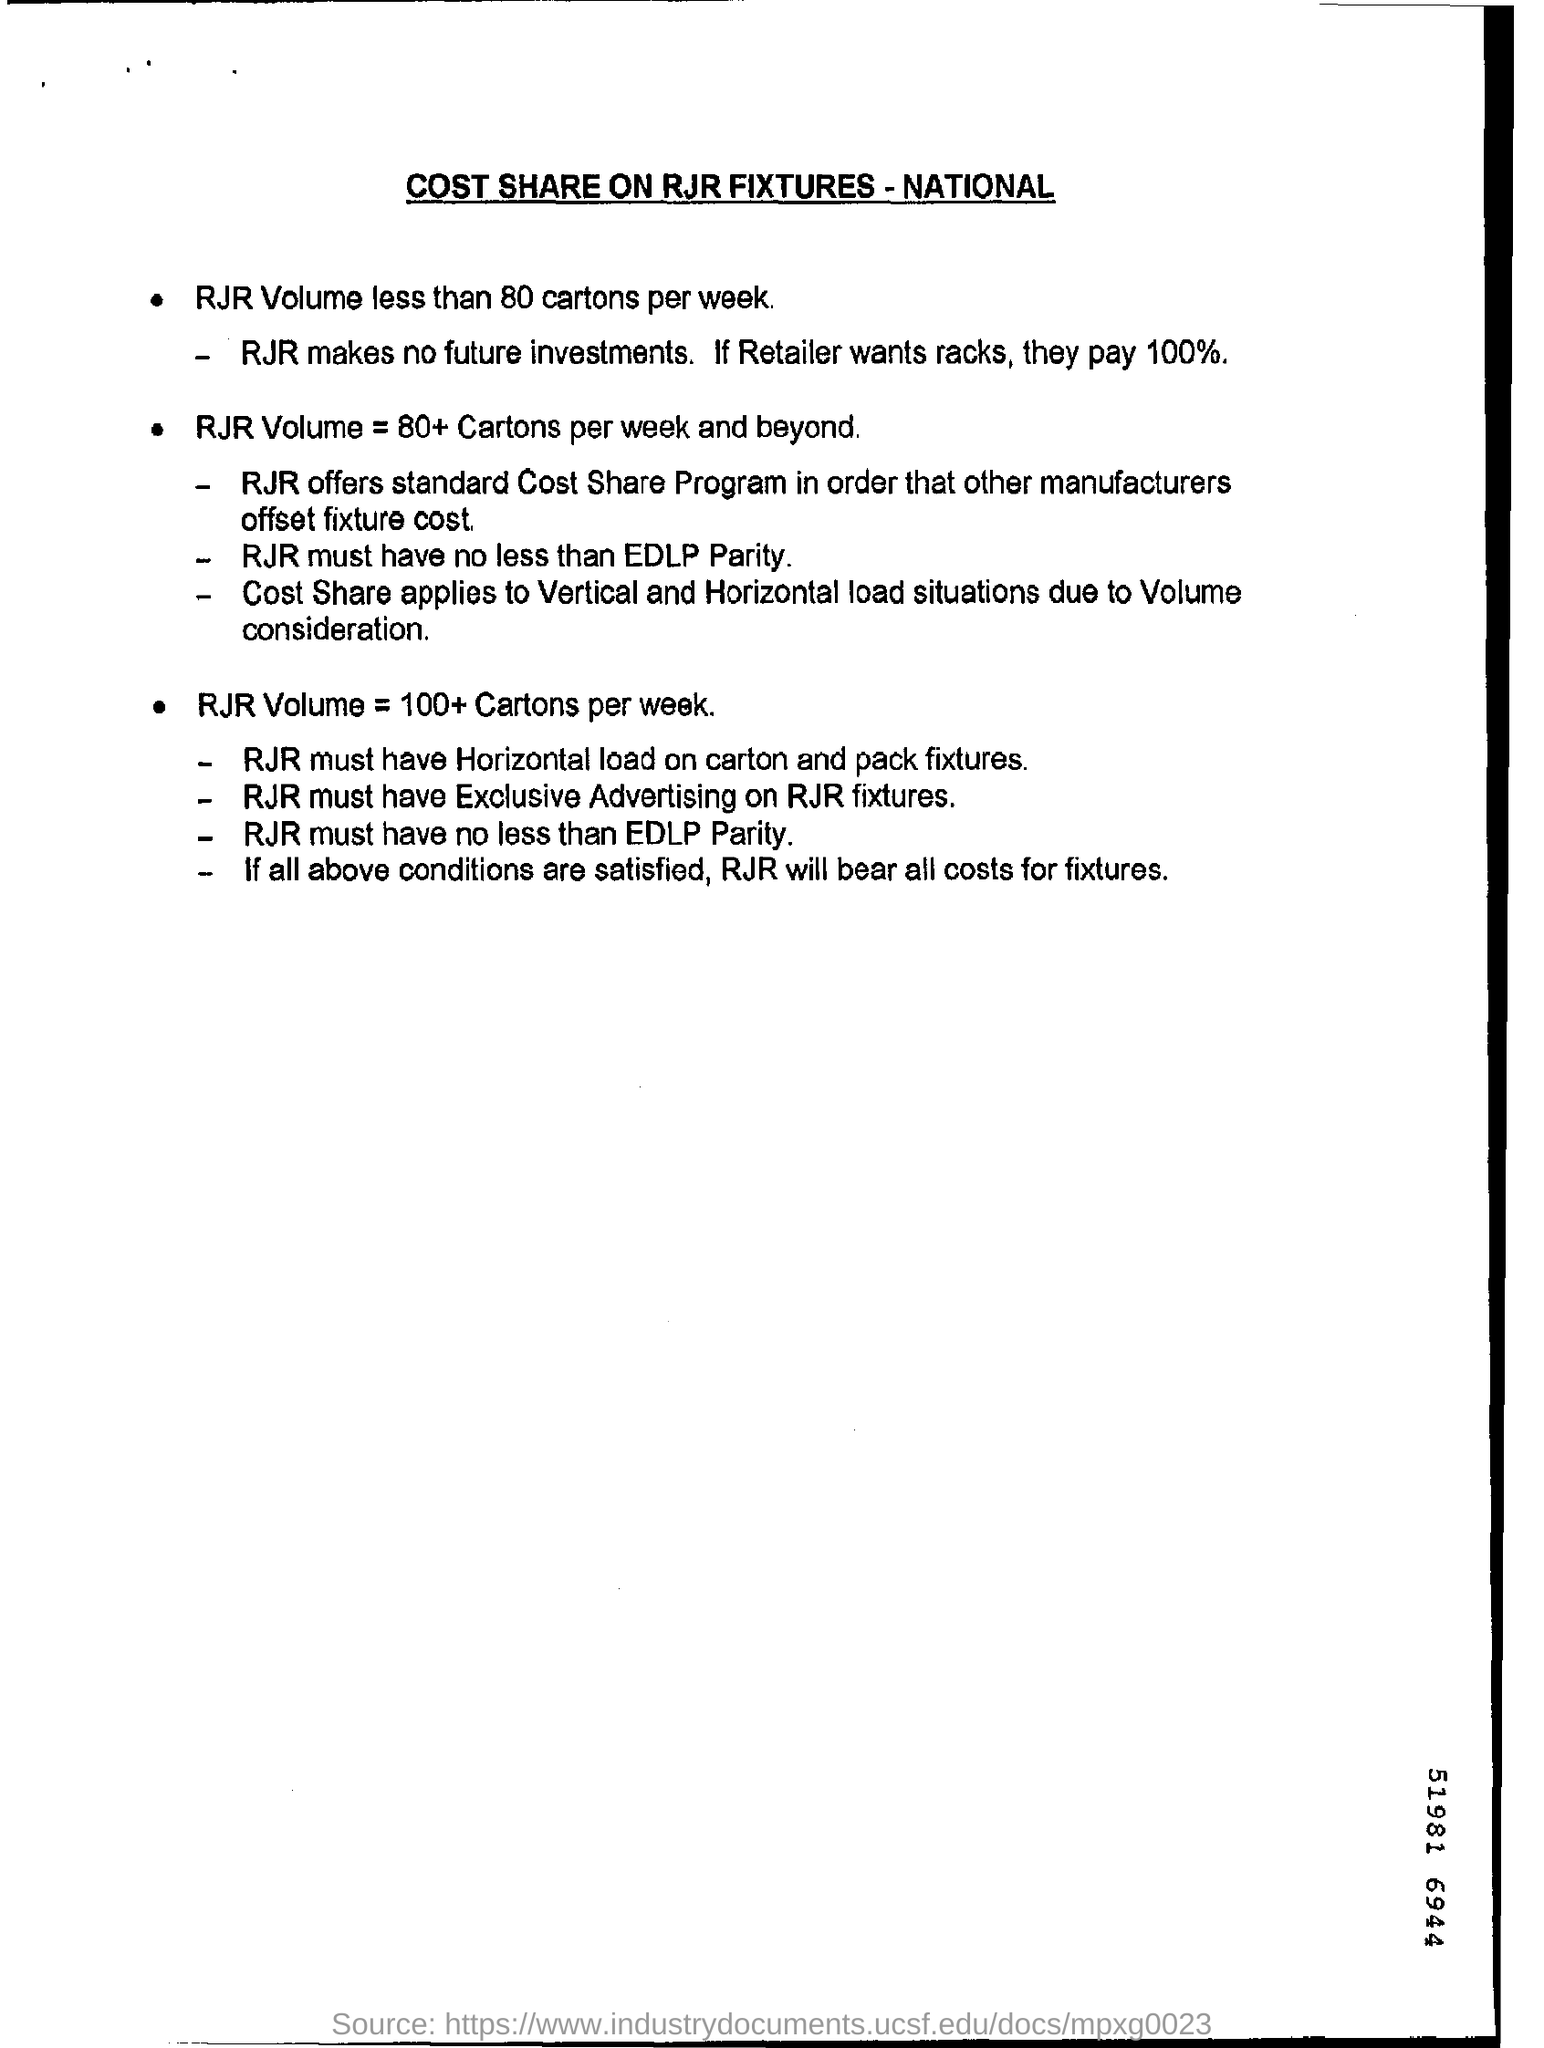What is the heading of the document?
Ensure brevity in your answer.  COST SHARE ON RJR FIXTURES - NATIONAL. If the retailer wants racks how much should he pay?
Offer a terse response. 100%. 